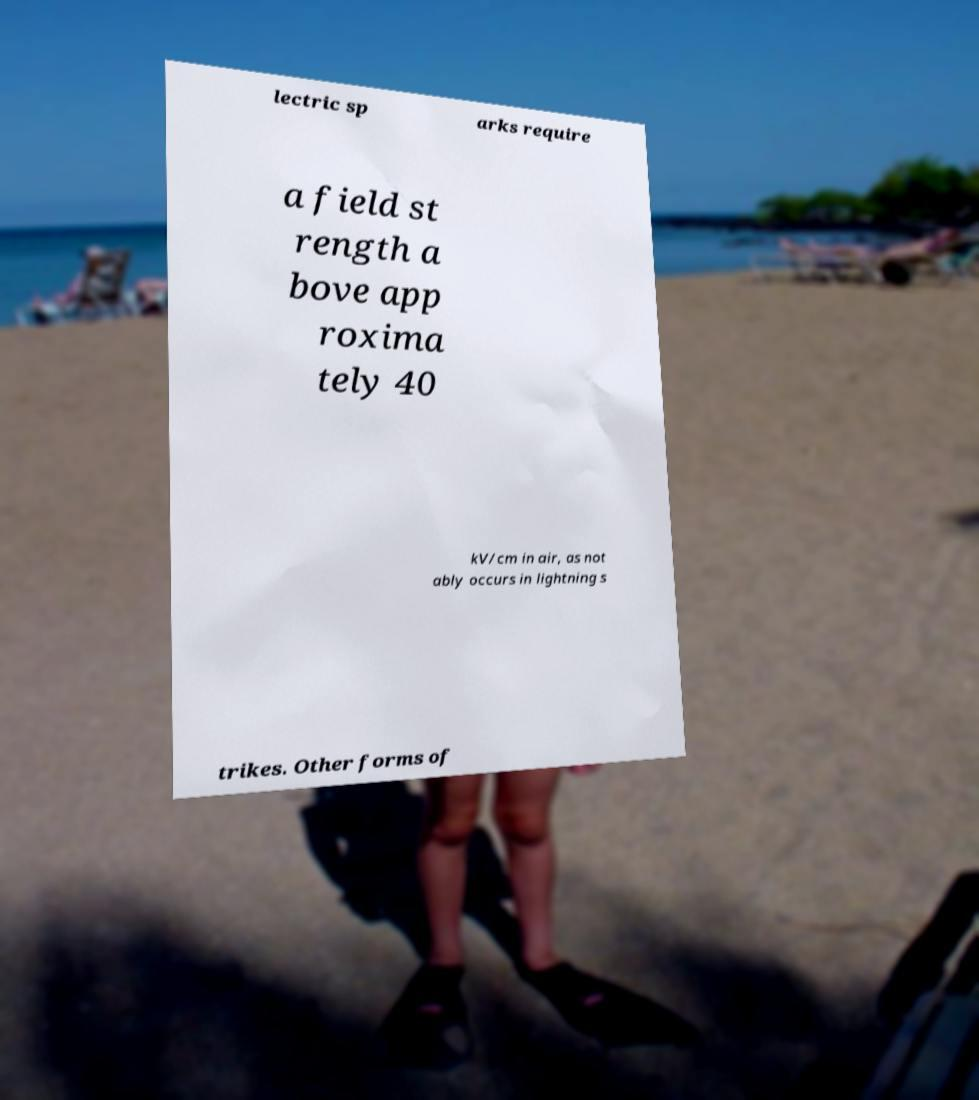Could you assist in decoding the text presented in this image and type it out clearly? lectric sp arks require a field st rength a bove app roxima tely 40 kV/cm in air, as not ably occurs in lightning s trikes. Other forms of 